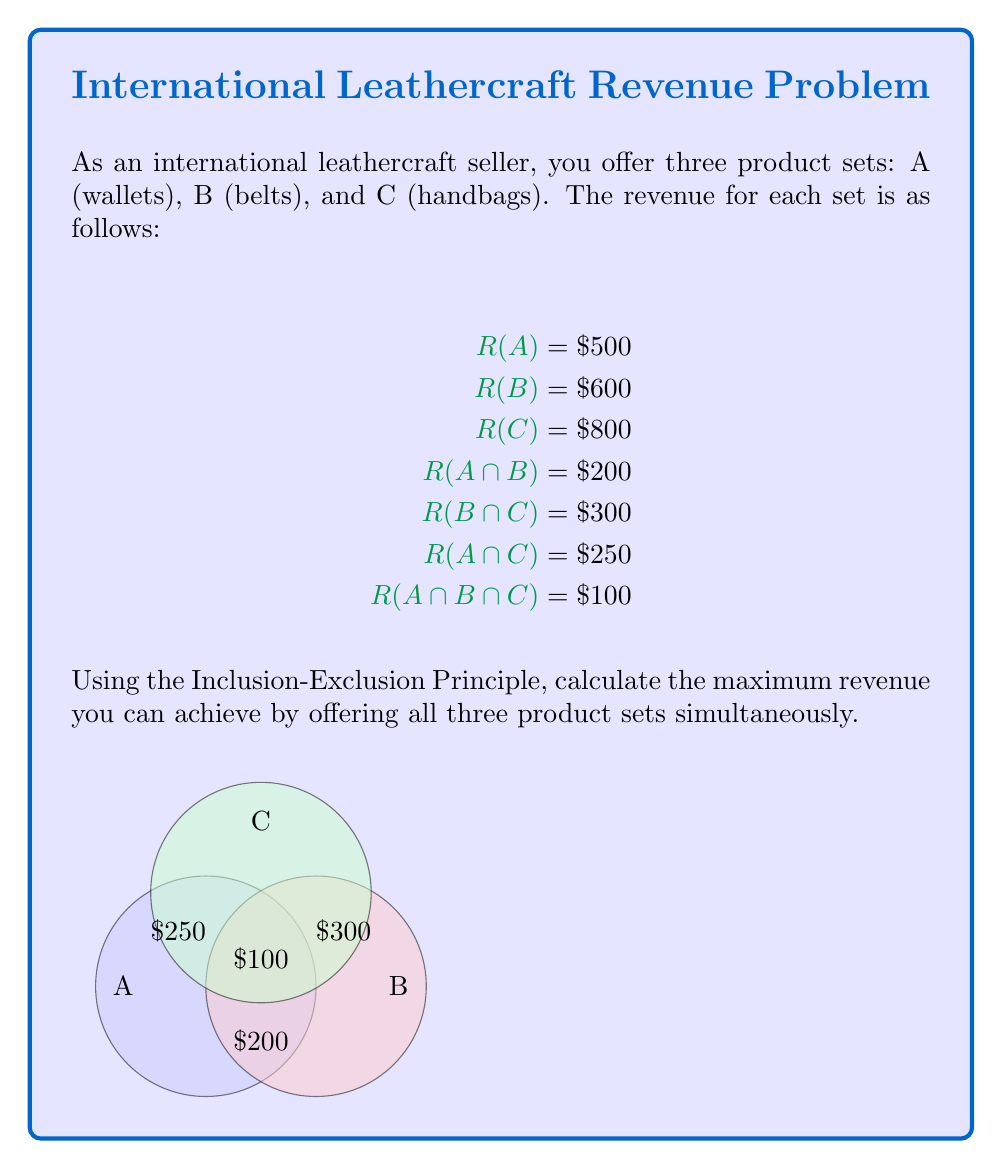Can you answer this question? To solve this problem, we'll use the Inclusion-Exclusion Principle for three sets. The formula for the union of three sets is:

$$|A \cup B \cup C| = |A| + |B| + |C| - |A \cap B| - |B \cap C| - |A \cap C| + |A \cap B \cap C|$$

In our case, we're dealing with revenue instead of set cardinality, so we'll replace the vertical bars with R():

$$R(A \cup B \cup C) = R(A) + R(B) + R(C) - R(A \cap B) - R(B \cap C) - R(A \cap C) + R(A \cap B \cap C)$$

Now, let's substitute the given values:

$$
\begin{aligned}
R(A \cup B \cup C) &= 500 + 600 + 800 - 200 - 300 - 250 + 100 \\
&= 1900 - 750 + 100 \\
&= 1250
\end{aligned}
$$

Therefore, the maximum revenue you can achieve by offering all three product sets simultaneously is $1250.
Answer: $1250 